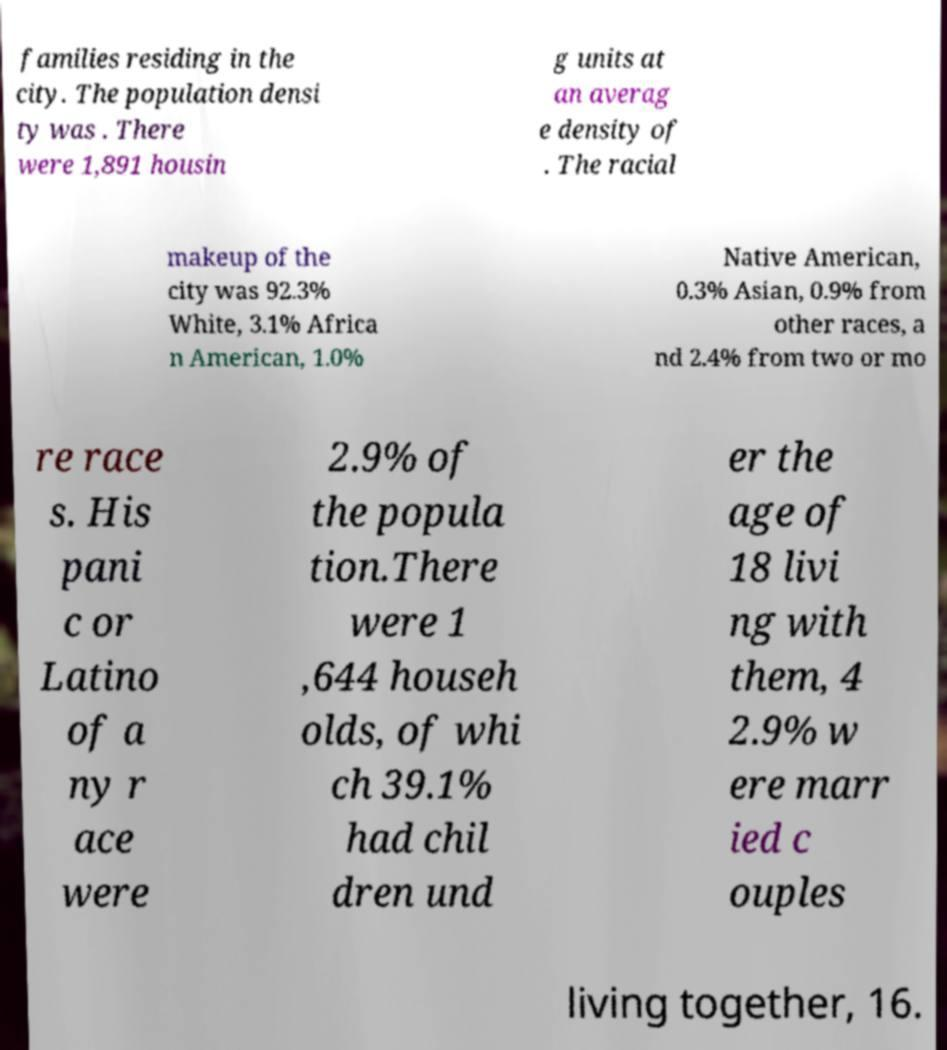What messages or text are displayed in this image? I need them in a readable, typed format. families residing in the city. The population densi ty was . There were 1,891 housin g units at an averag e density of . The racial makeup of the city was 92.3% White, 3.1% Africa n American, 1.0% Native American, 0.3% Asian, 0.9% from other races, a nd 2.4% from two or mo re race s. His pani c or Latino of a ny r ace were 2.9% of the popula tion.There were 1 ,644 househ olds, of whi ch 39.1% had chil dren und er the age of 18 livi ng with them, 4 2.9% w ere marr ied c ouples living together, 16. 